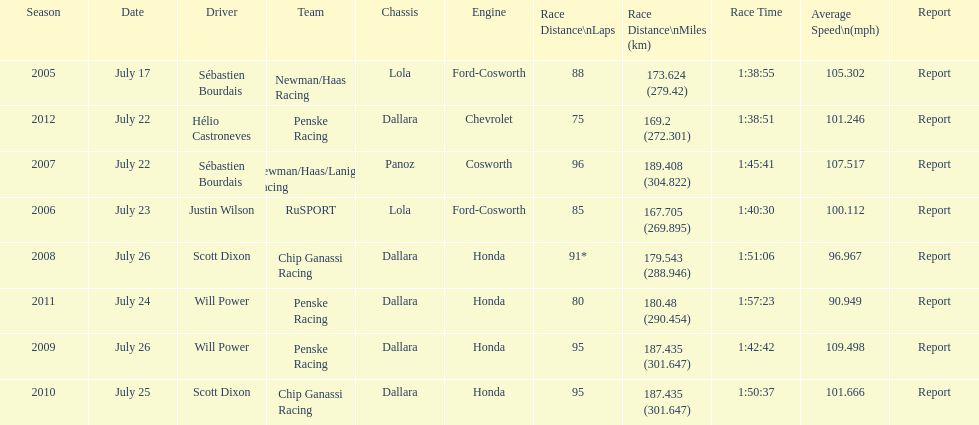Which team won the champ car world series the year before rusport? Newman/Haas Racing. 